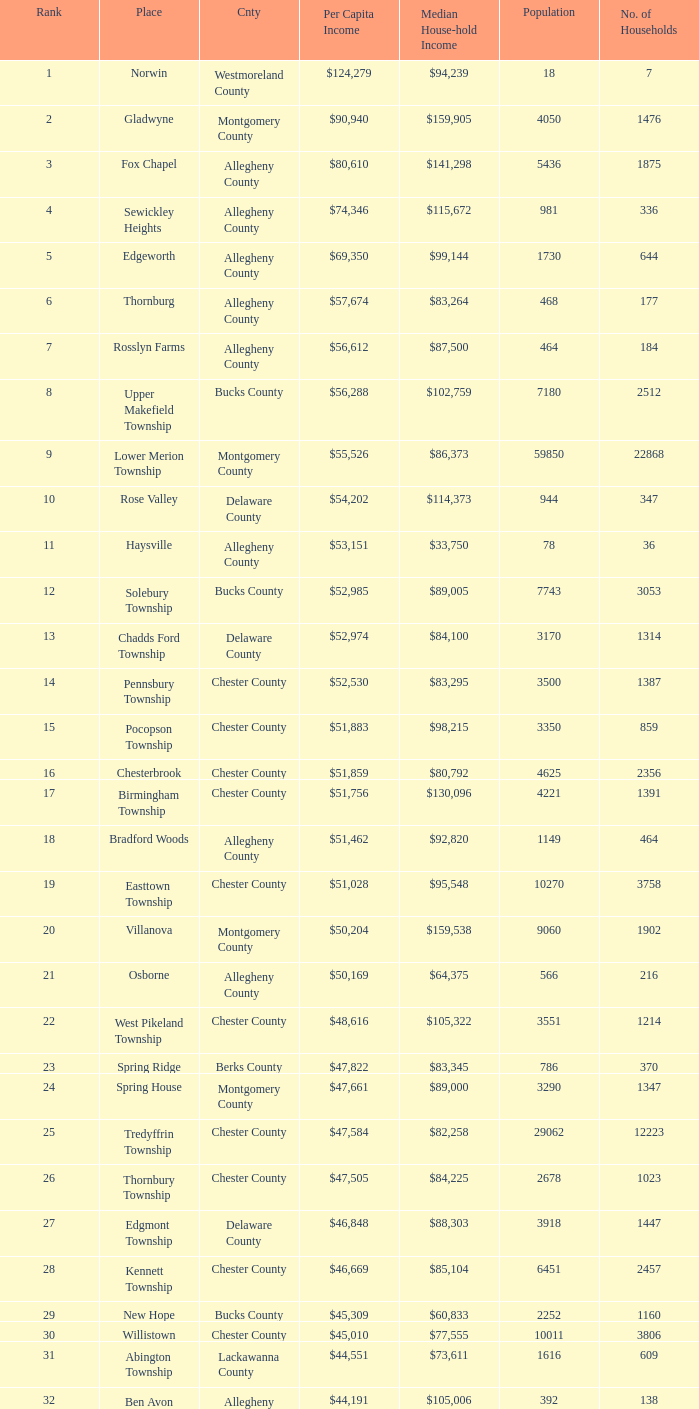Which place has a rank of 71? Wyomissing. 